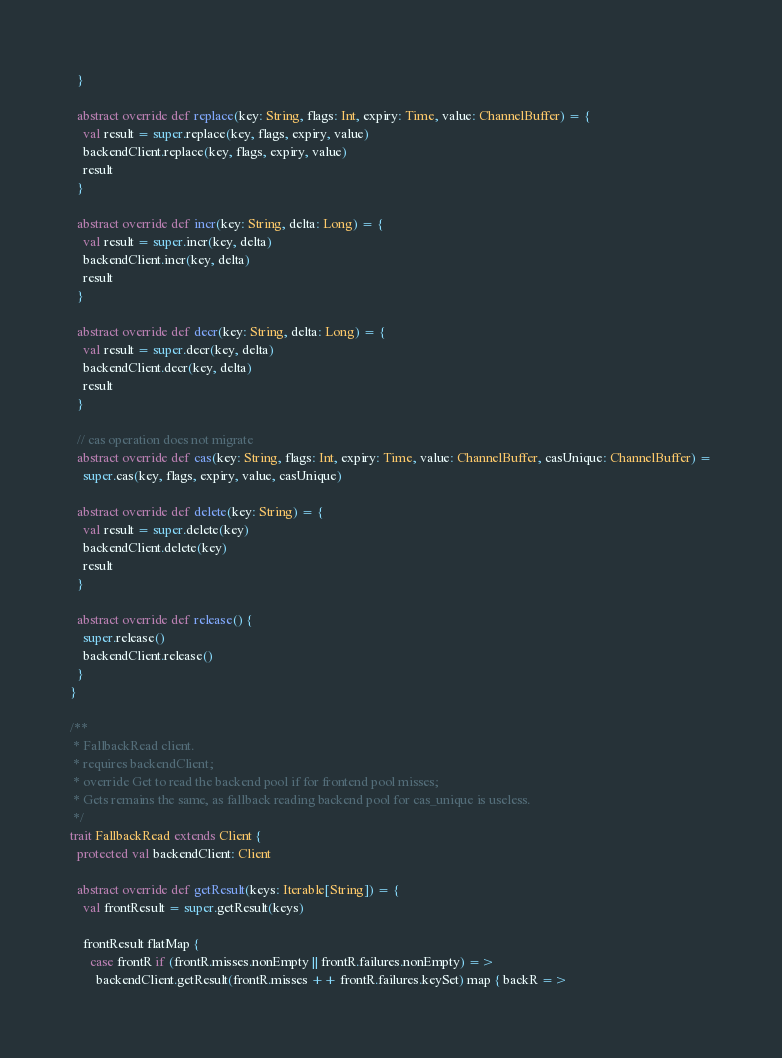<code> <loc_0><loc_0><loc_500><loc_500><_Scala_>  }

  abstract override def replace(key: String, flags: Int, expiry: Time, value: ChannelBuffer) = {
    val result = super.replace(key, flags, expiry, value)
    backendClient.replace(key, flags, expiry, value)
    result
  }

  abstract override def incr(key: String, delta: Long) = {
    val result = super.incr(key, delta)
    backendClient.incr(key, delta)
    result
  }

  abstract override def decr(key: String, delta: Long) = {
    val result = super.decr(key, delta)
    backendClient.decr(key, delta)
    result
  }

  // cas operation does not migrate
  abstract override def cas(key: String, flags: Int, expiry: Time, value: ChannelBuffer, casUnique: ChannelBuffer) =
    super.cas(key, flags, expiry, value, casUnique)

  abstract override def delete(key: String) = {
    val result = super.delete(key)
    backendClient.delete(key)
    result
  }

  abstract override def release() {
    super.release()
    backendClient.release()
  }
}

/**
 * FallbackRead client.
 * requires backendClient;
 * override Get to read the backend pool if for frontend pool misses;
 * Gets remains the same, as fallback reading backend pool for cas_unique is useless.
 */
trait FallbackRead extends Client {
  protected val backendClient: Client

  abstract override def getResult(keys: Iterable[String]) = {
    val frontResult = super.getResult(keys)

    frontResult flatMap {
      case frontR if (frontR.misses.nonEmpty || frontR.failures.nonEmpty) =>
        backendClient.getResult(frontR.misses ++ frontR.failures.keySet) map { backR =></code> 